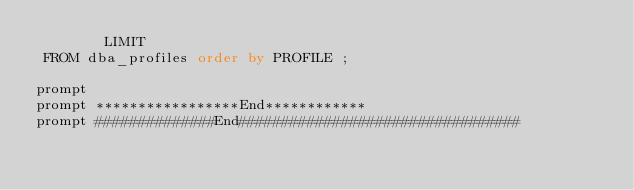<code> <loc_0><loc_0><loc_500><loc_500><_SQL_>				LIMIT
 FROM dba_profiles order by PROFILE ;

prompt
prompt *****************End************
prompt ##############End#################################
</code> 